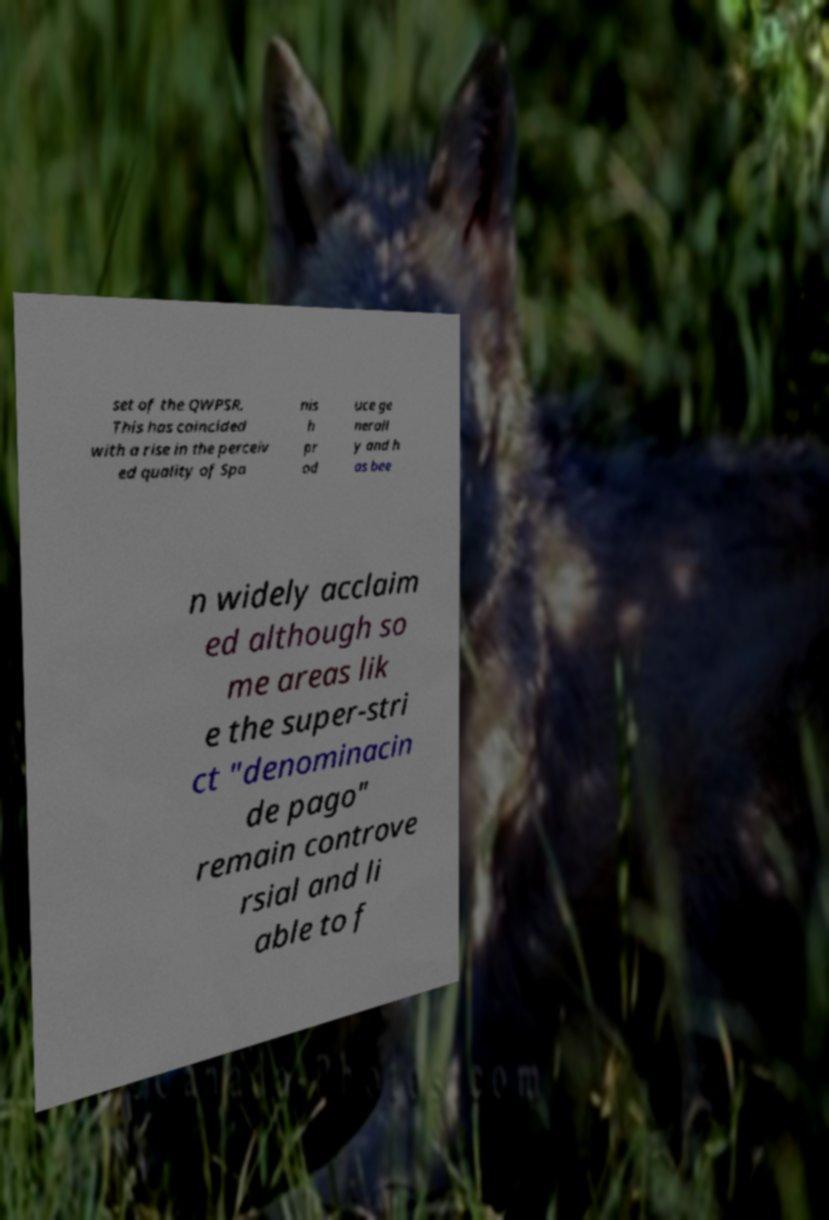There's text embedded in this image that I need extracted. Can you transcribe it verbatim? set of the QWPSR. This has coincided with a rise in the perceiv ed quality of Spa nis h pr od uce ge nerall y and h as bee n widely acclaim ed although so me areas lik e the super-stri ct "denominacin de pago" remain controve rsial and li able to f 